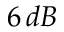<formula> <loc_0><loc_0><loc_500><loc_500>6 \, d B</formula> 